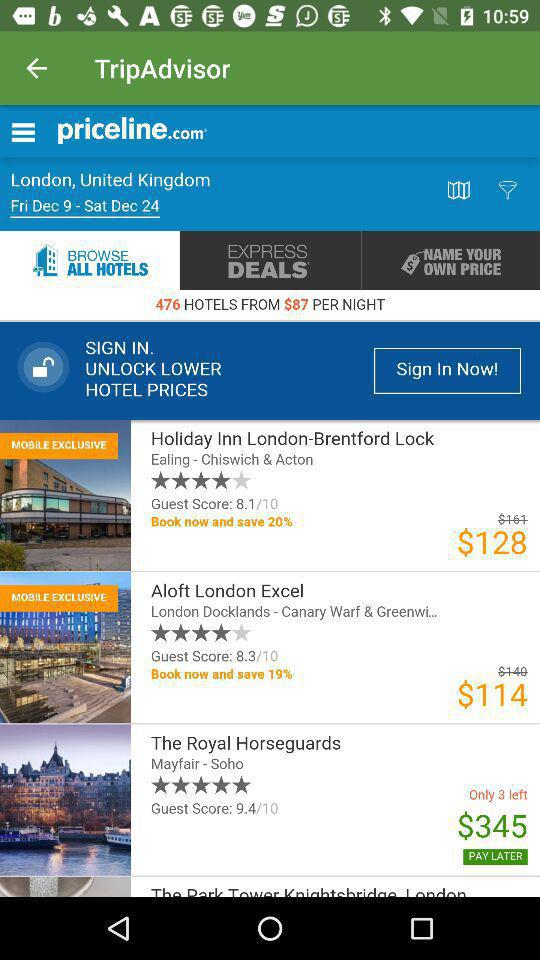What is the discounted booking price of a room in the hotel "Holiday Inn London-Brentford Lock"? The discounted booking price of a room in the hotel "Holiday Inn London-Brentford Lock" is $128. 